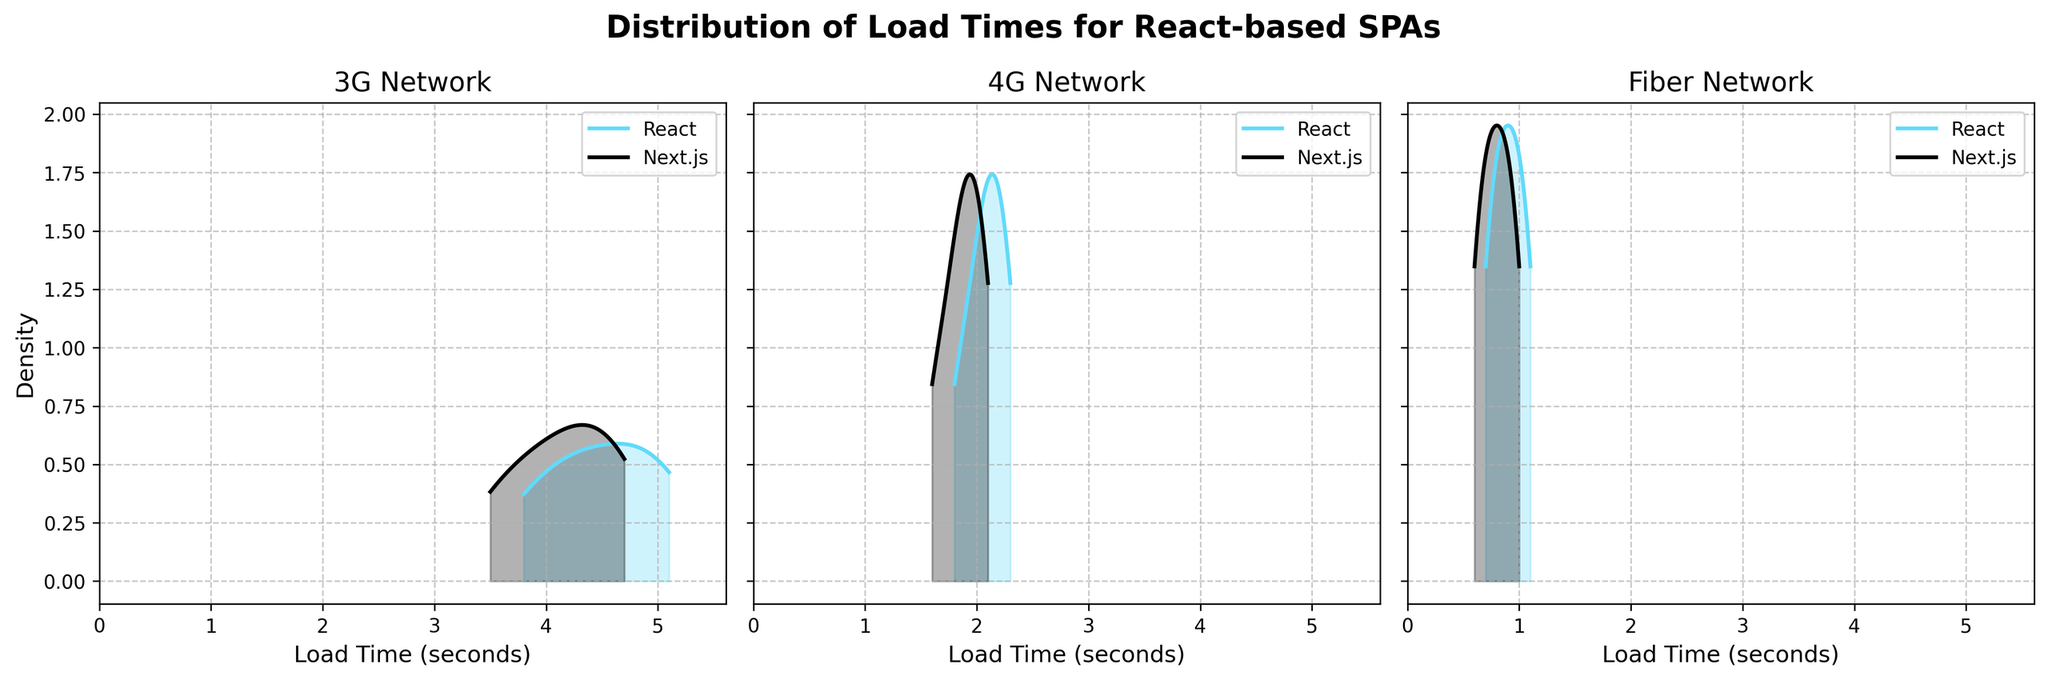What is the title of the figure? The title is usually located at the top of the figure and summarizes the content of the plots. Here, we can see it says "Distribution of Load Times for React-based SPAs."
Answer: Distribution of Load Times for React-based SPAs What framework is represented by the color blue? By observing the color legend at the top of each subplot, it's noted that the color blue represents React.
Answer: React Which network condition has the highest density peak for React? By comparing the peaks of the density plots for React across all subplots, we see that the Fiber network condition has the highest density peak.
Answer: Fiber How do the load times for Next.js under the 4G network compare to those under the 3G network? By examining the density plots for Next.js under both the 4G and 3G network conditions, the plot for 4G shows a distribution that is shifted to the left, indicating lower load times and thus faster loading compared to the 3G network condition.
Answer: Next.js has faster load times under 4G than 3G Which framework shows a greater difference in load times between the 3G and Fiber network conditions? By comparing the spread and peak of the density plots for both frameworks in the 3G and Fiber network conditions, React shows a more significant difference in density peaks and spread, indicating a greater difference in load times.
Answer: React What is the x-axis label of the subplots? The x-axis label is usually located at the bottom of each subplot and indicates the type of data plotted. Here, it is labeled "Load Time (seconds)."
Answer: Load Time (seconds) Which framework tends to have more consistent load times under the Fiber network condition? By observing the density plots under Fiber, the densities for both frameworks have similar shapes, but the peak for Next.js is higher, suggesting more consistent load times.
Answer: Next.js In the 4G network condition, which framework has a wider spread of load times? By visually comparing the width of the density plots under the 4G network condition, the spread of the density plot for React is slightly wider than that for Next.js.
Answer: React What's the general trend in load time when moving from 3G to Fiber network conditions for React? Observing the three subplots for the React framework, the density peaks shift to the left as we move from 3G to 4G to Fiber, indicating decreasing load times.
Answer: Load times decrease Are the load times for React and Next.js overlapping under the same network conditions? In each network condition subplot, the density plots for React and Next.js do overlap, indicating that there are load times common to both frameworks.
Answer: Yes 